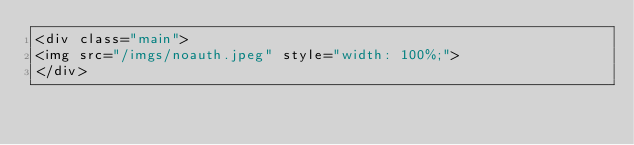<code> <loc_0><loc_0><loc_500><loc_500><_PHP_><div class="main">
<img src="/imgs/noauth.jpeg" style="width: 100%;">
</div>
</code> 